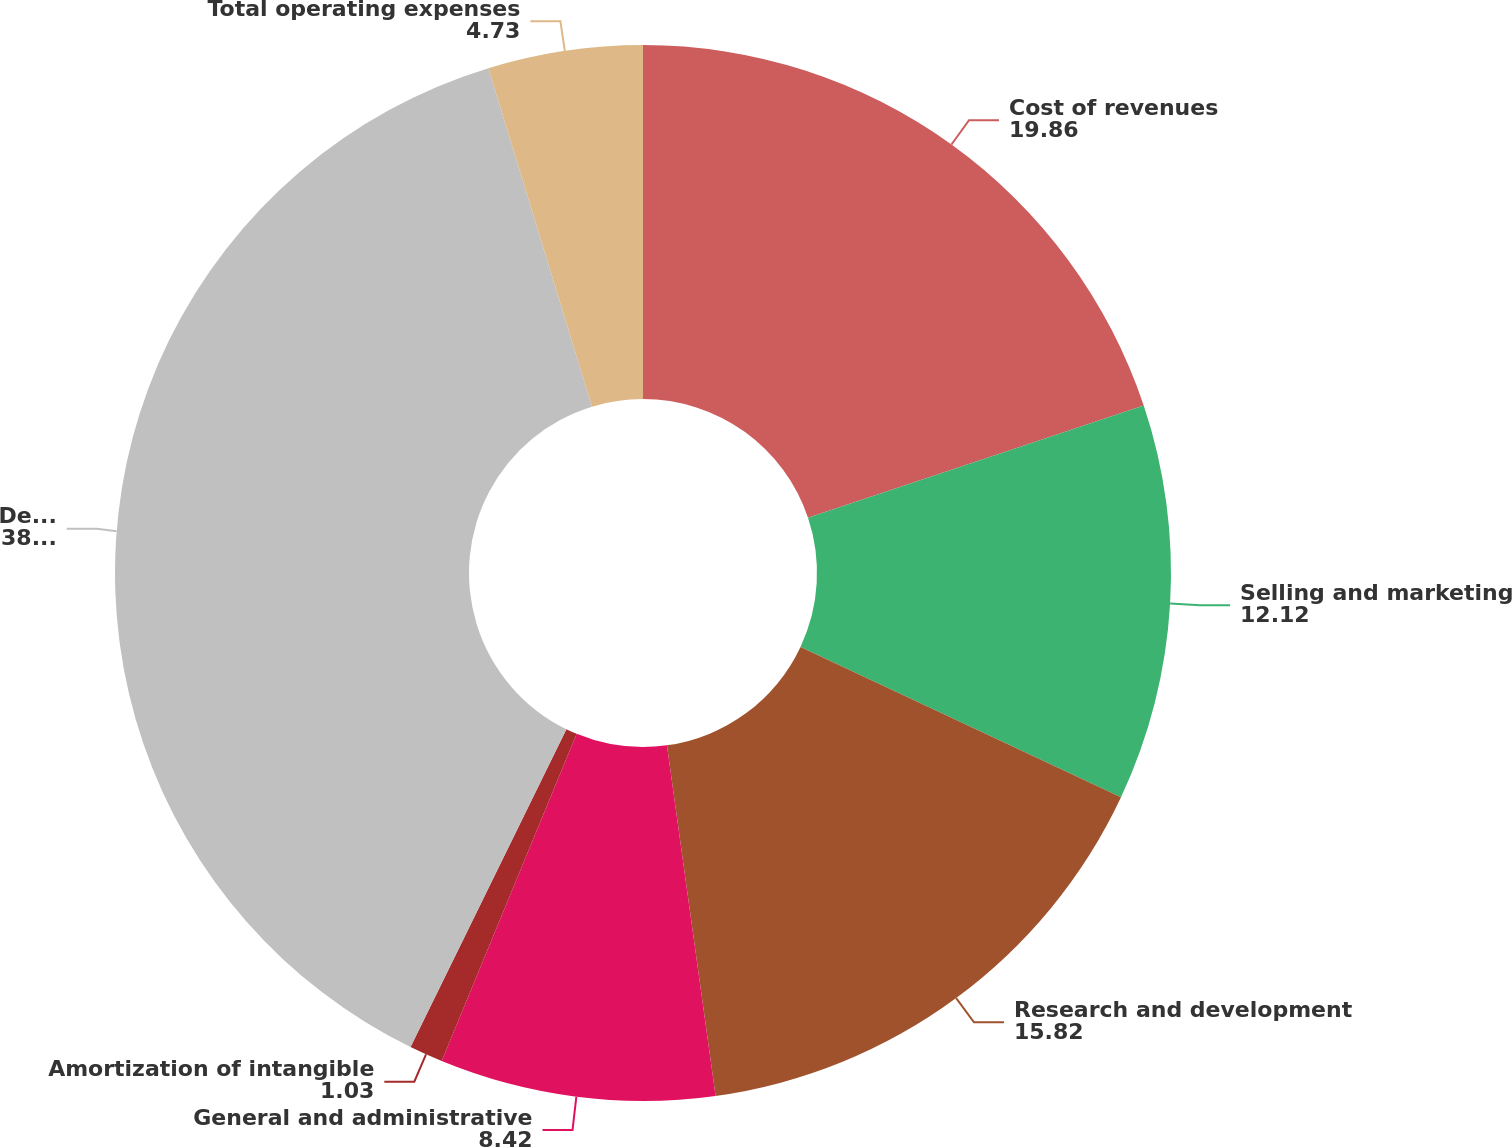Convert chart. <chart><loc_0><loc_0><loc_500><loc_500><pie_chart><fcel>Cost of revenues<fcel>Selling and marketing<fcel>Research and development<fcel>General and administrative<fcel>Amortization of intangible<fcel>Depreciation and amortization<fcel>Total operating expenses<nl><fcel>19.86%<fcel>12.12%<fcel>15.82%<fcel>8.42%<fcel>1.03%<fcel>38.01%<fcel>4.73%<nl></chart> 